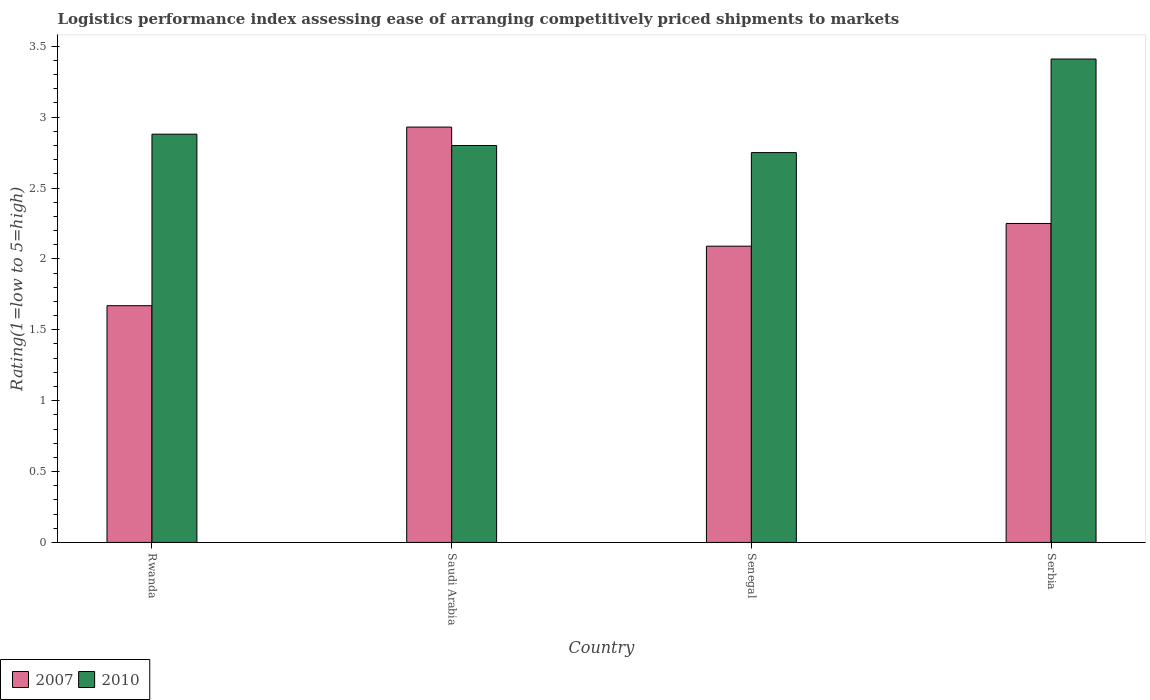How many bars are there on the 1st tick from the right?
Offer a very short reply. 2. What is the label of the 3rd group of bars from the left?
Offer a very short reply. Senegal. In how many cases, is the number of bars for a given country not equal to the number of legend labels?
Ensure brevity in your answer.  0. Across all countries, what is the maximum Logistic performance index in 2007?
Give a very brief answer. 2.93. Across all countries, what is the minimum Logistic performance index in 2007?
Your answer should be compact. 1.67. In which country was the Logistic performance index in 2007 maximum?
Provide a short and direct response. Saudi Arabia. In which country was the Logistic performance index in 2010 minimum?
Provide a succinct answer. Senegal. What is the total Logistic performance index in 2007 in the graph?
Give a very brief answer. 8.94. What is the difference between the Logistic performance index in 2010 in Saudi Arabia and that in Serbia?
Give a very brief answer. -0.61. What is the difference between the Logistic performance index in 2007 in Senegal and the Logistic performance index in 2010 in Rwanda?
Provide a succinct answer. -0.79. What is the average Logistic performance index in 2007 per country?
Keep it short and to the point. 2.23. What is the difference between the Logistic performance index of/in 2007 and Logistic performance index of/in 2010 in Saudi Arabia?
Your response must be concise. 0.13. What is the ratio of the Logistic performance index in 2007 in Saudi Arabia to that in Serbia?
Your response must be concise. 1.3. Is the Logistic performance index in 2010 in Rwanda less than that in Senegal?
Ensure brevity in your answer.  No. Is the difference between the Logistic performance index in 2007 in Rwanda and Serbia greater than the difference between the Logistic performance index in 2010 in Rwanda and Serbia?
Your response must be concise. No. What is the difference between the highest and the second highest Logistic performance index in 2010?
Your answer should be very brief. -0.53. What is the difference between the highest and the lowest Logistic performance index in 2010?
Ensure brevity in your answer.  0.66. What does the 2nd bar from the left in Rwanda represents?
Your answer should be compact. 2010. How many bars are there?
Your answer should be compact. 8. Are all the bars in the graph horizontal?
Ensure brevity in your answer.  No. Where does the legend appear in the graph?
Your answer should be very brief. Bottom left. How many legend labels are there?
Keep it short and to the point. 2. How are the legend labels stacked?
Your answer should be very brief. Horizontal. What is the title of the graph?
Offer a terse response. Logistics performance index assessing ease of arranging competitively priced shipments to markets. What is the label or title of the X-axis?
Give a very brief answer. Country. What is the label or title of the Y-axis?
Provide a short and direct response. Rating(1=low to 5=high). What is the Rating(1=low to 5=high) of 2007 in Rwanda?
Keep it short and to the point. 1.67. What is the Rating(1=low to 5=high) in 2010 in Rwanda?
Provide a succinct answer. 2.88. What is the Rating(1=low to 5=high) in 2007 in Saudi Arabia?
Keep it short and to the point. 2.93. What is the Rating(1=low to 5=high) in 2007 in Senegal?
Make the answer very short. 2.09. What is the Rating(1=low to 5=high) in 2010 in Senegal?
Your response must be concise. 2.75. What is the Rating(1=low to 5=high) of 2007 in Serbia?
Give a very brief answer. 2.25. What is the Rating(1=low to 5=high) in 2010 in Serbia?
Offer a terse response. 3.41. Across all countries, what is the maximum Rating(1=low to 5=high) in 2007?
Make the answer very short. 2.93. Across all countries, what is the maximum Rating(1=low to 5=high) in 2010?
Offer a terse response. 3.41. Across all countries, what is the minimum Rating(1=low to 5=high) in 2007?
Give a very brief answer. 1.67. Across all countries, what is the minimum Rating(1=low to 5=high) of 2010?
Keep it short and to the point. 2.75. What is the total Rating(1=low to 5=high) in 2007 in the graph?
Ensure brevity in your answer.  8.94. What is the total Rating(1=low to 5=high) in 2010 in the graph?
Ensure brevity in your answer.  11.84. What is the difference between the Rating(1=low to 5=high) of 2007 in Rwanda and that in Saudi Arabia?
Your response must be concise. -1.26. What is the difference between the Rating(1=low to 5=high) of 2007 in Rwanda and that in Senegal?
Offer a terse response. -0.42. What is the difference between the Rating(1=low to 5=high) of 2010 in Rwanda and that in Senegal?
Offer a terse response. 0.13. What is the difference between the Rating(1=low to 5=high) in 2007 in Rwanda and that in Serbia?
Provide a succinct answer. -0.58. What is the difference between the Rating(1=low to 5=high) of 2010 in Rwanda and that in Serbia?
Ensure brevity in your answer.  -0.53. What is the difference between the Rating(1=low to 5=high) of 2007 in Saudi Arabia and that in Senegal?
Your answer should be compact. 0.84. What is the difference between the Rating(1=low to 5=high) in 2007 in Saudi Arabia and that in Serbia?
Your answer should be compact. 0.68. What is the difference between the Rating(1=low to 5=high) of 2010 in Saudi Arabia and that in Serbia?
Offer a terse response. -0.61. What is the difference between the Rating(1=low to 5=high) of 2007 in Senegal and that in Serbia?
Provide a short and direct response. -0.16. What is the difference between the Rating(1=low to 5=high) of 2010 in Senegal and that in Serbia?
Offer a very short reply. -0.66. What is the difference between the Rating(1=low to 5=high) in 2007 in Rwanda and the Rating(1=low to 5=high) in 2010 in Saudi Arabia?
Provide a succinct answer. -1.13. What is the difference between the Rating(1=low to 5=high) in 2007 in Rwanda and the Rating(1=low to 5=high) in 2010 in Senegal?
Ensure brevity in your answer.  -1.08. What is the difference between the Rating(1=low to 5=high) in 2007 in Rwanda and the Rating(1=low to 5=high) in 2010 in Serbia?
Offer a terse response. -1.74. What is the difference between the Rating(1=low to 5=high) of 2007 in Saudi Arabia and the Rating(1=low to 5=high) of 2010 in Senegal?
Keep it short and to the point. 0.18. What is the difference between the Rating(1=low to 5=high) of 2007 in Saudi Arabia and the Rating(1=low to 5=high) of 2010 in Serbia?
Provide a short and direct response. -0.48. What is the difference between the Rating(1=low to 5=high) of 2007 in Senegal and the Rating(1=low to 5=high) of 2010 in Serbia?
Provide a succinct answer. -1.32. What is the average Rating(1=low to 5=high) in 2007 per country?
Keep it short and to the point. 2.23. What is the average Rating(1=low to 5=high) of 2010 per country?
Make the answer very short. 2.96. What is the difference between the Rating(1=low to 5=high) of 2007 and Rating(1=low to 5=high) of 2010 in Rwanda?
Your answer should be compact. -1.21. What is the difference between the Rating(1=low to 5=high) in 2007 and Rating(1=low to 5=high) in 2010 in Saudi Arabia?
Your response must be concise. 0.13. What is the difference between the Rating(1=low to 5=high) in 2007 and Rating(1=low to 5=high) in 2010 in Senegal?
Your answer should be very brief. -0.66. What is the difference between the Rating(1=low to 5=high) in 2007 and Rating(1=low to 5=high) in 2010 in Serbia?
Your response must be concise. -1.16. What is the ratio of the Rating(1=low to 5=high) in 2007 in Rwanda to that in Saudi Arabia?
Ensure brevity in your answer.  0.57. What is the ratio of the Rating(1=low to 5=high) in 2010 in Rwanda to that in Saudi Arabia?
Offer a very short reply. 1.03. What is the ratio of the Rating(1=low to 5=high) in 2007 in Rwanda to that in Senegal?
Make the answer very short. 0.8. What is the ratio of the Rating(1=low to 5=high) of 2010 in Rwanda to that in Senegal?
Provide a succinct answer. 1.05. What is the ratio of the Rating(1=low to 5=high) in 2007 in Rwanda to that in Serbia?
Provide a succinct answer. 0.74. What is the ratio of the Rating(1=low to 5=high) of 2010 in Rwanda to that in Serbia?
Ensure brevity in your answer.  0.84. What is the ratio of the Rating(1=low to 5=high) in 2007 in Saudi Arabia to that in Senegal?
Keep it short and to the point. 1.4. What is the ratio of the Rating(1=low to 5=high) in 2010 in Saudi Arabia to that in Senegal?
Provide a succinct answer. 1.02. What is the ratio of the Rating(1=low to 5=high) in 2007 in Saudi Arabia to that in Serbia?
Provide a succinct answer. 1.3. What is the ratio of the Rating(1=low to 5=high) in 2010 in Saudi Arabia to that in Serbia?
Offer a terse response. 0.82. What is the ratio of the Rating(1=low to 5=high) of 2007 in Senegal to that in Serbia?
Your answer should be very brief. 0.93. What is the ratio of the Rating(1=low to 5=high) of 2010 in Senegal to that in Serbia?
Your answer should be very brief. 0.81. What is the difference between the highest and the second highest Rating(1=low to 5=high) of 2007?
Your answer should be compact. 0.68. What is the difference between the highest and the second highest Rating(1=low to 5=high) of 2010?
Your response must be concise. 0.53. What is the difference between the highest and the lowest Rating(1=low to 5=high) in 2007?
Your answer should be very brief. 1.26. What is the difference between the highest and the lowest Rating(1=low to 5=high) in 2010?
Provide a short and direct response. 0.66. 